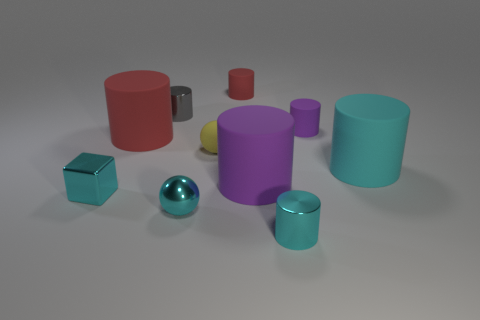What shape is the large purple rubber object?
Provide a short and direct response. Cylinder. How many objects are either things that are to the left of the tiny yellow thing or cyan shiny objects?
Offer a very short reply. 5. How many other objects are there of the same color as the small shiny block?
Give a very brief answer. 3. There is a tiny metal ball; does it have the same color as the cylinder that is in front of the cyan metallic cube?
Your response must be concise. Yes. There is another tiny metallic object that is the same shape as the tiny gray metal thing; what is its color?
Keep it short and to the point. Cyan. Is the tiny yellow ball made of the same material as the cylinder that is on the left side of the gray metal cylinder?
Offer a very short reply. Yes. What color is the small block?
Make the answer very short. Cyan. There is a small cylinder that is to the left of the red matte cylinder on the right side of the big red cylinder that is on the left side of the cyan metal cylinder; what color is it?
Make the answer very short. Gray. Do the gray shiny thing and the large thing behind the big cyan matte thing have the same shape?
Keep it short and to the point. Yes. What color is the tiny matte object that is both to the left of the large purple cylinder and in front of the gray cylinder?
Offer a very short reply. Yellow. 